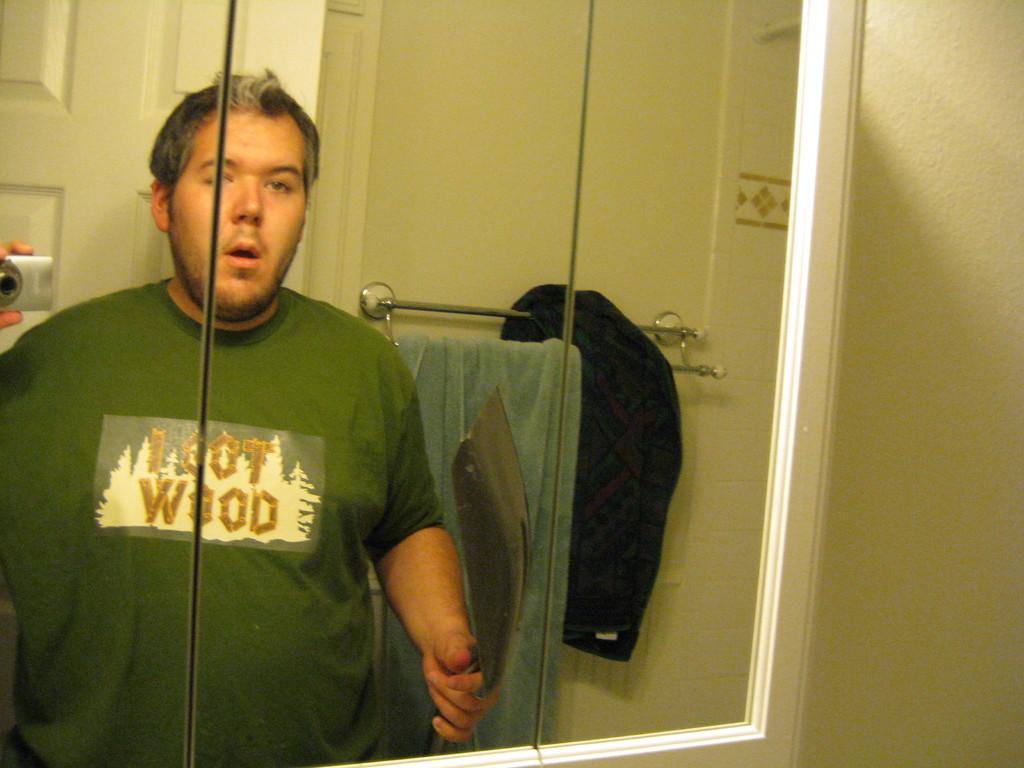<image>
Give a short and clear explanation of the subsequent image. a person with a shirt that says wood in the mirror 